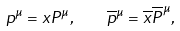Convert formula to latex. <formula><loc_0><loc_0><loc_500><loc_500>p ^ { \mu } = x P ^ { \mu } , \quad \overline { p } ^ { \mu } = \overline { x } \overline { P } ^ { \mu } ,</formula> 